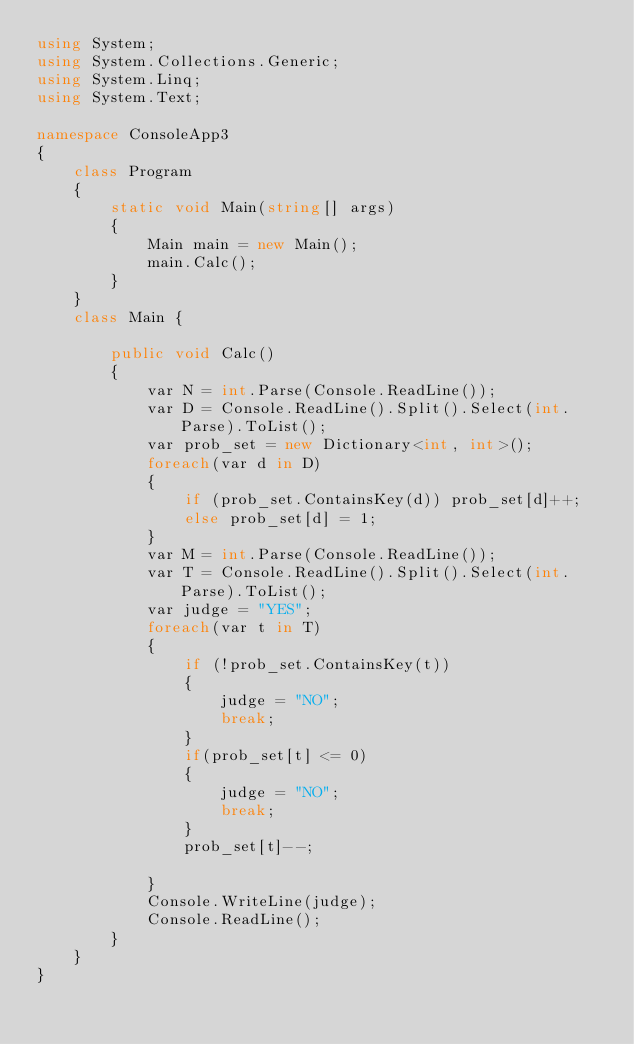<code> <loc_0><loc_0><loc_500><loc_500><_C#_>using System;
using System.Collections.Generic;
using System.Linq;
using System.Text;

namespace ConsoleApp3
{
    class Program
    {
        static void Main(string[] args)
        {
            Main main = new Main();
            main.Calc();
        }
    }
    class Main { 

        public void Calc()
        {
            var N = int.Parse(Console.ReadLine());
            var D = Console.ReadLine().Split().Select(int.Parse).ToList();
            var prob_set = new Dictionary<int, int>();
            foreach(var d in D)
            {
                if (prob_set.ContainsKey(d)) prob_set[d]++;
                else prob_set[d] = 1;
            }
            var M = int.Parse(Console.ReadLine());
            var T = Console.ReadLine().Split().Select(int.Parse).ToList();
            var judge = "YES";
            foreach(var t in T)
            {
                if (!prob_set.ContainsKey(t))
                {
                    judge = "NO";
                    break;
                }
                if(prob_set[t] <= 0)
                {
                    judge = "NO";
                    break;
                }
                prob_set[t]--;

            }
            Console.WriteLine(judge);
            Console.ReadLine();
        }
    }
}
</code> 